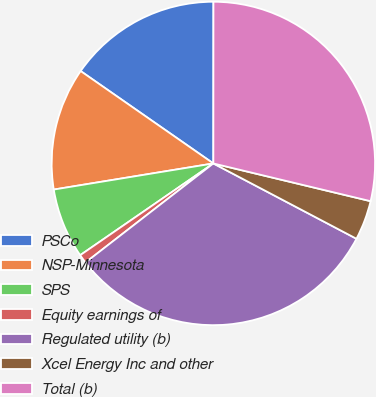Convert chart. <chart><loc_0><loc_0><loc_500><loc_500><pie_chart><fcel>PSCo<fcel>NSP-Minnesota<fcel>SPS<fcel>Equity earnings of<fcel>Regulated utility (b)<fcel>Xcel Energy Inc and other<fcel>Total (b)<nl><fcel>15.33%<fcel>12.26%<fcel>7.02%<fcel>0.89%<fcel>31.8%<fcel>3.96%<fcel>28.74%<nl></chart> 